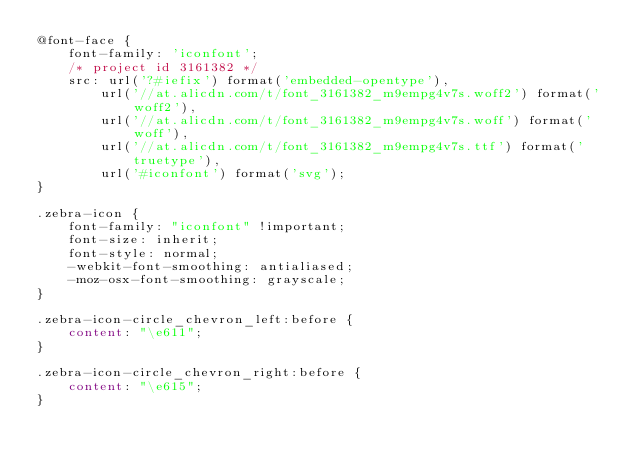<code> <loc_0><loc_0><loc_500><loc_500><_CSS_>@font-face {
	font-family: 'iconfont';
	/* project id 3161382 */
	src: url('?#iefix') format('embedded-opentype'),
		url('//at.alicdn.com/t/font_3161382_m9empg4v7s.woff2') format('woff2'),
		url('//at.alicdn.com/t/font_3161382_m9empg4v7s.woff') format('woff'),
		url('//at.alicdn.com/t/font_3161382_m9empg4v7s.ttf') format('truetype'),
		url('#iconfont') format('svg');
}

.zebra-icon {
	font-family: "iconfont" !important;
	font-size: inherit;
	font-style: normal;
	-webkit-font-smoothing: antialiased;
	-moz-osx-font-smoothing: grayscale;
}

.zebra-icon-circle_chevron_left:before {
	content: "\e611";
}

.zebra-icon-circle_chevron_right:before {
	content: "\e615";
}
</code> 